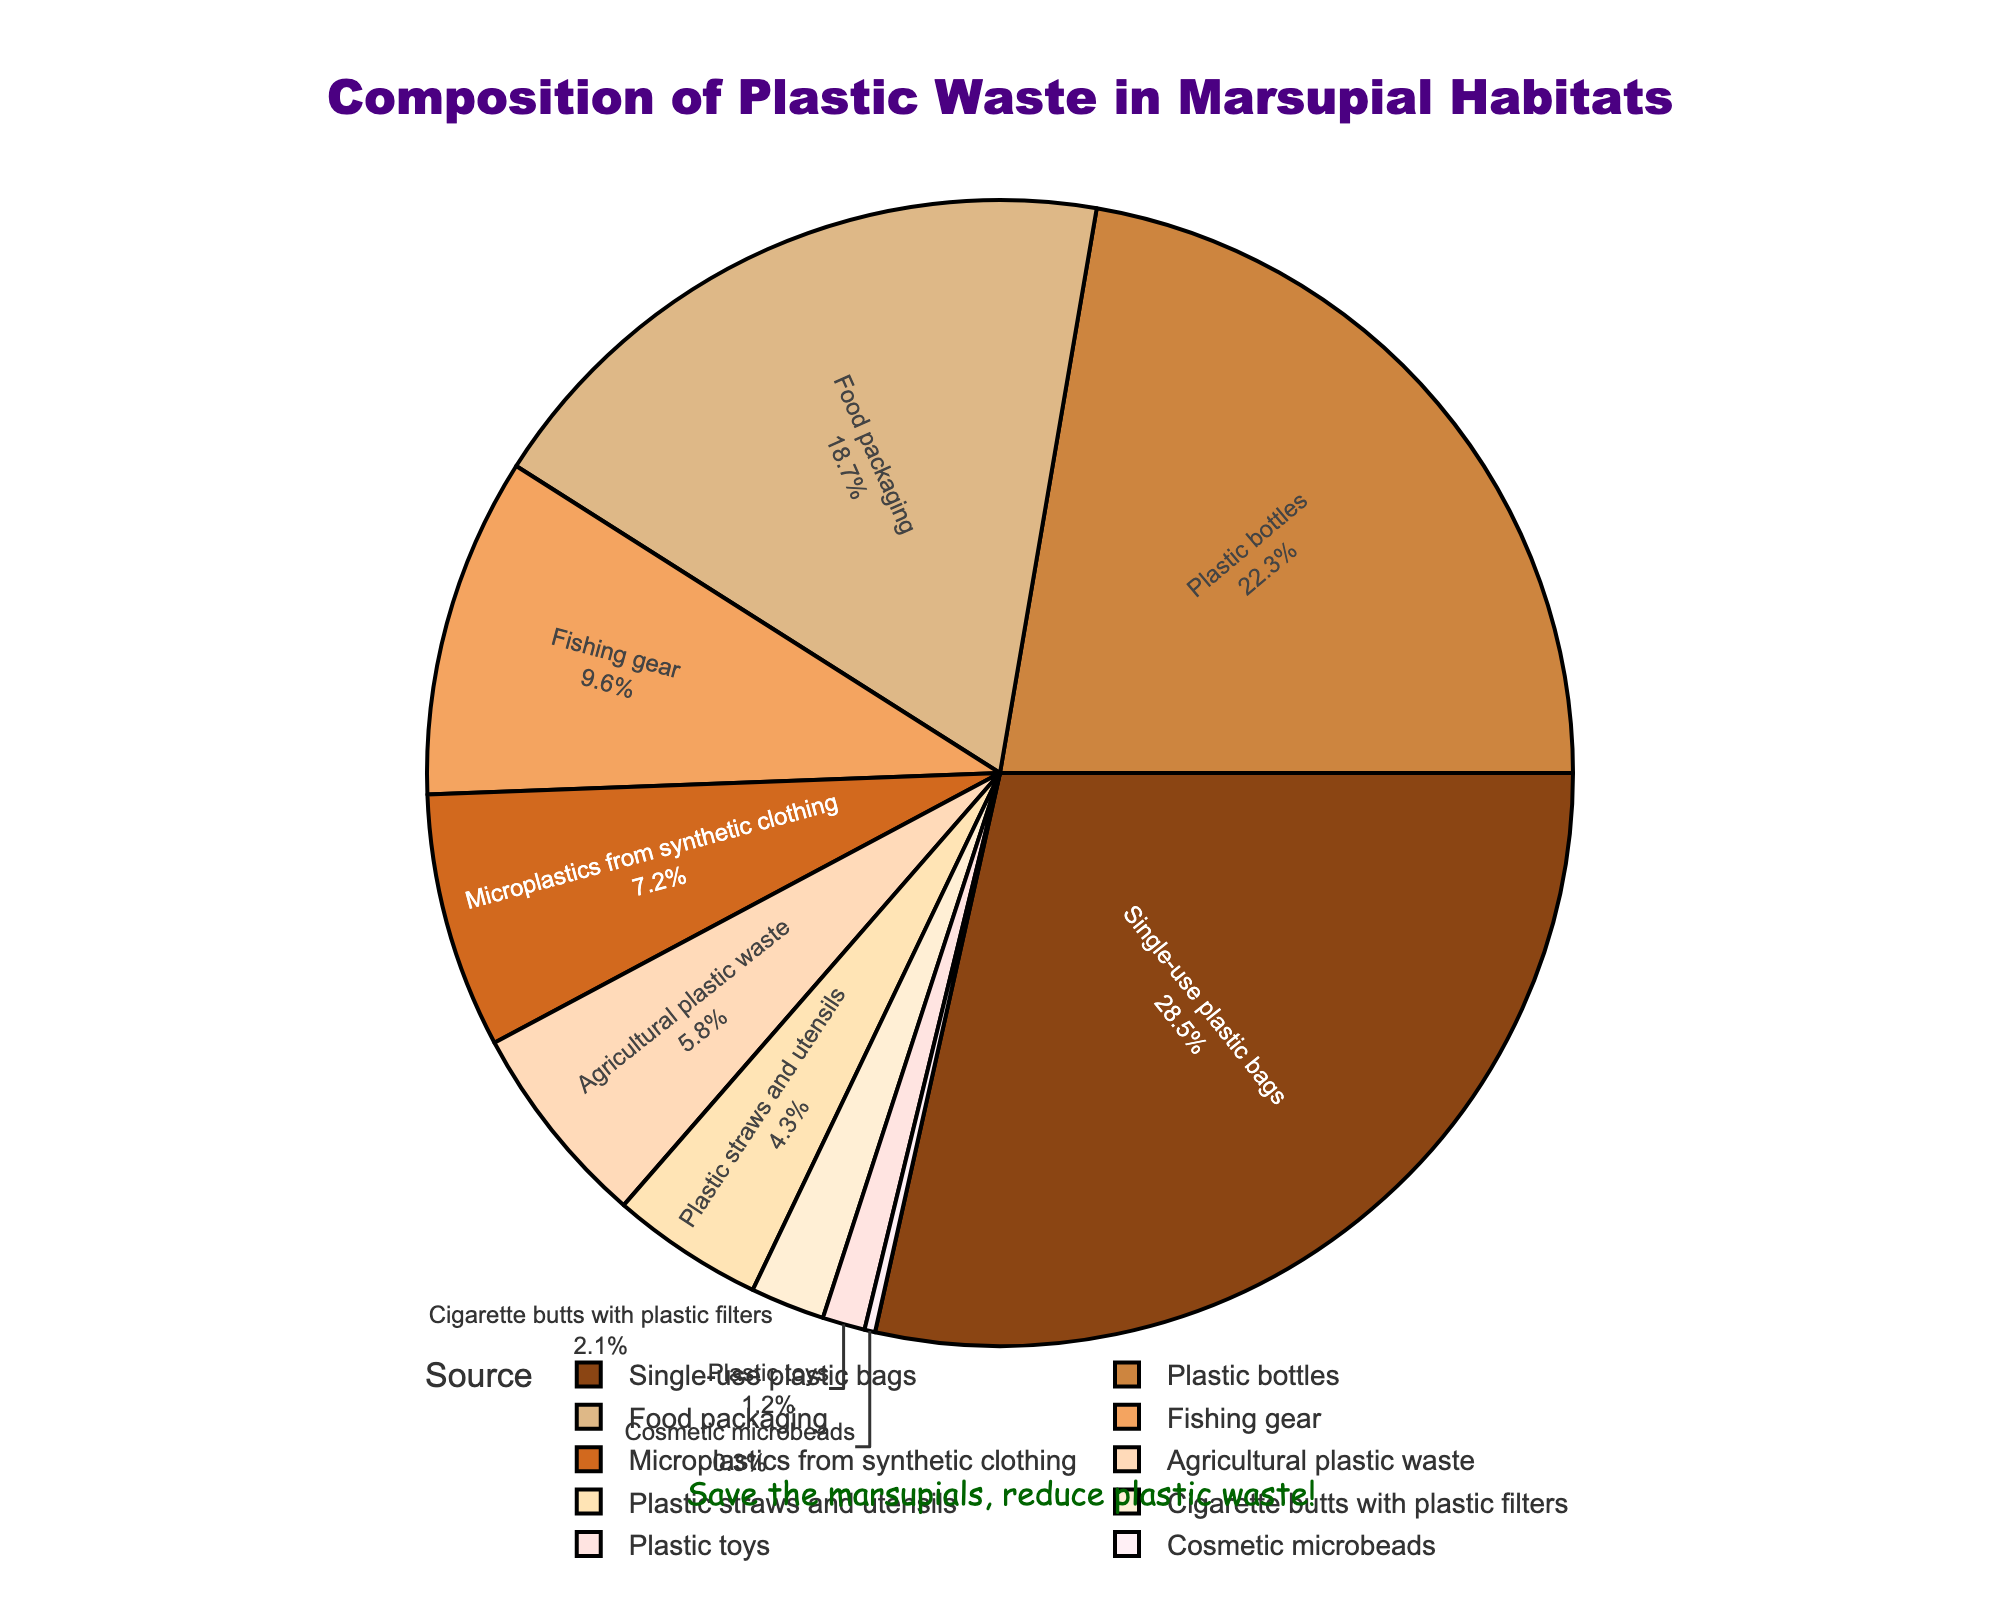What is the percentage composition of single-use plastic bags in marsupial habitats? The question is straightforward and only requires one to refer to the pie chart and locate the percentage value associated with single-use plastic bags.
Answer: 28.5% What are the top three contributors to plastic waste in marsupial habitats? To answer this, identify and list the sources with the highest percentage values by observing the pie chart. The data shows that single-use plastic bags (28.5%), plastic bottles (22.3%), and food packaging (18.7%) are the top three contributors.
Answer: Single-use plastic bags, plastic bottles, food packaging How much greater is the percentage of plastic bottles compared to plastic straws and utensils? Calculate the difference between the percentage values of plastic bottles (22.3%) and plastic straws and utensils (4.3%). The calculation is 22.3% - 4.3% = 18%.
Answer: 18% Which sources have a percentage less than 5%? Identify the sources on the pie chart with a percentage value below 5%. These are plastic straws and utensils (4.3%), cigarette butts with plastic filters (2.1%), plastic toys (1.2%), and cosmetic microbeads (0.3%).
Answer: Plastic straws and utensils, cigarette butts with plastic filters, plastic toys, cosmetic microbeads Among food packaging and fishing gear, which one has a higher percentage of plastic waste? Compare the percentage values of food packaging (18.7%) and fishing gear (9.6%) to determine which is higher.
Answer: Food packaging What is the combined percentage of microplastics from synthetic clothing and cosmetic microbeads? Add the percentage of microplastics from synthetic clothing (7.2%) and cosmetic microbeads (0.3%). The calculation is 7.2% + 0.3% = 7.5%.
Answer: 7.5% Which source of plastic waste is indicated by the largest section in the pie chart? The largest section in the pie chart corresponds to the source with the highest percentage value, which is single-use plastic bags at 28.5%.
Answer: Single-use plastic bags If agricultural plastic waste is removed, what would be the new total percentage of remaining sources? Subtract the percentage of agricultural plastic waste (5.8%) from 100% to find the new total percentage. Calculation: 100% - 5.8% = 94.2%.
Answer: 94.2% What is the difference in percentage between the highest and lowest contributors of plastic waste? Subtract the percentage of the lowest contributor (cosmetic microbeads at 0.3%) from the highest contributor (single-use plastic bags at 28.5%). Calculation: 28.5% - 0.3% = 28.2%.
Answer: 28.2% 